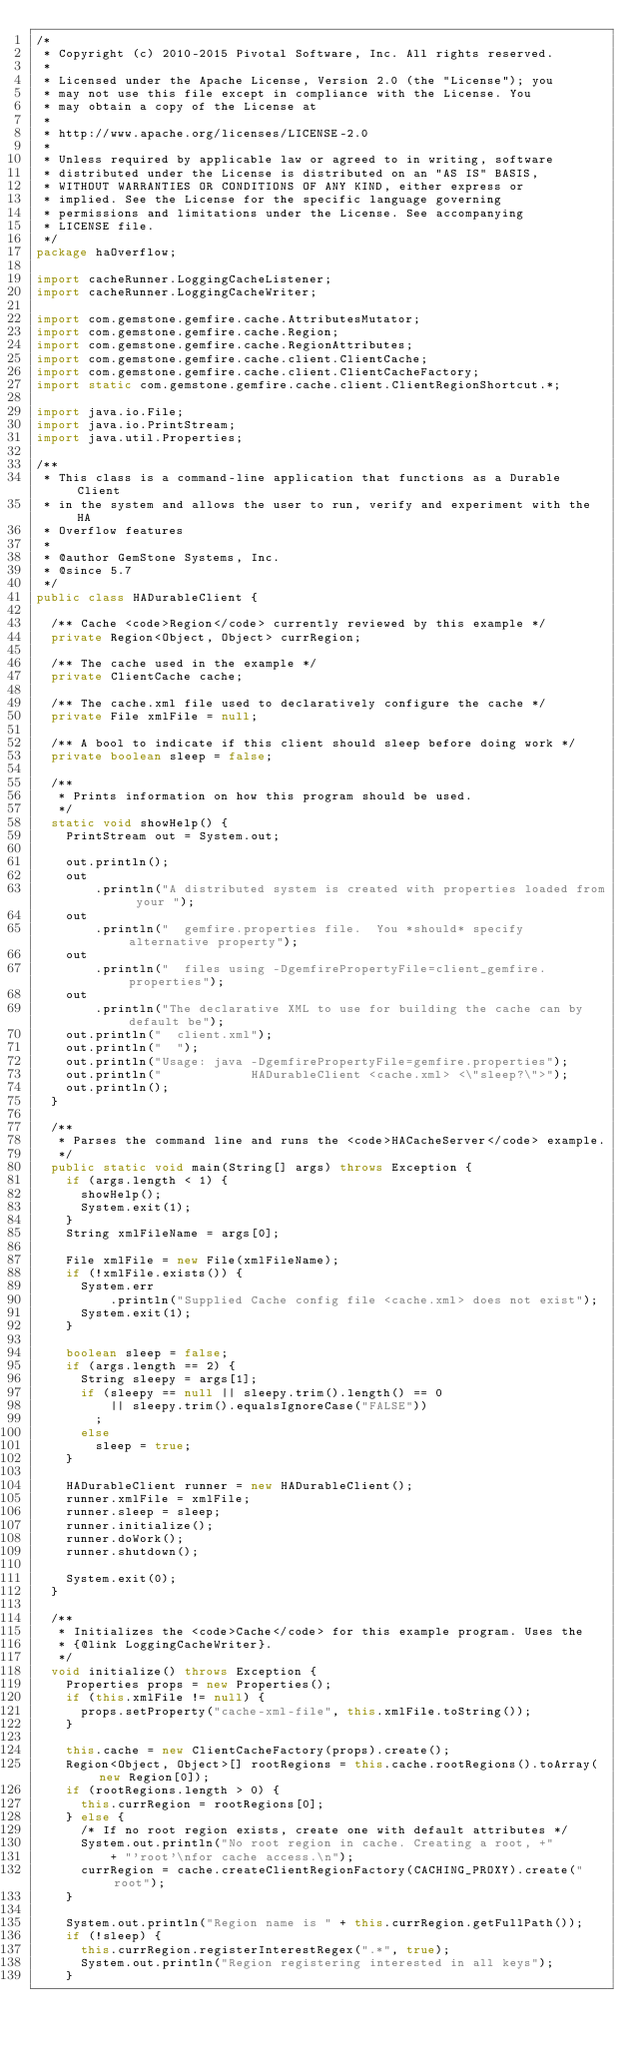Convert code to text. <code><loc_0><loc_0><loc_500><loc_500><_Java_>/*
 * Copyright (c) 2010-2015 Pivotal Software, Inc. All rights reserved.
 *
 * Licensed under the Apache License, Version 2.0 (the "License"); you
 * may not use this file except in compliance with the License. You
 * may obtain a copy of the License at
 *
 * http://www.apache.org/licenses/LICENSE-2.0
 *
 * Unless required by applicable law or agreed to in writing, software
 * distributed under the License is distributed on an "AS IS" BASIS,
 * WITHOUT WARRANTIES OR CONDITIONS OF ANY KIND, either express or
 * implied. See the License for the specific language governing
 * permissions and limitations under the License. See accompanying
 * LICENSE file.
 */
package haOverflow;

import cacheRunner.LoggingCacheListener;
import cacheRunner.LoggingCacheWriter;

import com.gemstone.gemfire.cache.AttributesMutator;
import com.gemstone.gemfire.cache.Region;
import com.gemstone.gemfire.cache.RegionAttributes;
import com.gemstone.gemfire.cache.client.ClientCache;
import com.gemstone.gemfire.cache.client.ClientCacheFactory;
import static com.gemstone.gemfire.cache.client.ClientRegionShortcut.*;

import java.io.File;
import java.io.PrintStream;
import java.util.Properties;

/**
 * This class is a command-line application that functions as a Durable Client
 * in the system and allows the user to run, verify and experiment with the HA
 * Overflow features
 * 
 * @author GemStone Systems, Inc.
 * @since 5.7
 */
public class HADurableClient {

  /** Cache <code>Region</code> currently reviewed by this example */
  private Region<Object, Object> currRegion;

  /** The cache used in the example */
  private ClientCache cache;

  /** The cache.xml file used to declaratively configure the cache */
  private File xmlFile = null;

  /** A bool to indicate if this client should sleep before doing work */
  private boolean sleep = false;

  /**
   * Prints information on how this program should be used.
   */
  static void showHelp() {
    PrintStream out = System.out;

    out.println();
    out
        .println("A distributed system is created with properties loaded from your ");
    out
        .println("  gemfire.properties file.  You *should* specify alternative property");
    out
        .println("  files using -DgemfirePropertyFile=client_gemfire.properties");
    out
        .println("The declarative XML to use for building the cache can by default be");
    out.println("  client.xml");
    out.println("  ");
    out.println("Usage: java -DgemfirePropertyFile=gemfire.properties");
    out.println("            HADurableClient <cache.xml> <\"sleep?\">");
    out.println();
  }

  /**
   * Parses the command line and runs the <code>HACacheServer</code> example.
   */
  public static void main(String[] args) throws Exception {
    if (args.length < 1) {
      showHelp();
      System.exit(1);
    }
    String xmlFileName = args[0];

    File xmlFile = new File(xmlFileName);
    if (!xmlFile.exists()) {
      System.err
          .println("Supplied Cache config file <cache.xml> does not exist");
      System.exit(1);
    }

    boolean sleep = false;
    if (args.length == 2) {
      String sleepy = args[1];
      if (sleepy == null || sleepy.trim().length() == 0
          || sleepy.trim().equalsIgnoreCase("FALSE"))
        ;
      else
        sleep = true;
    }

    HADurableClient runner = new HADurableClient();
    runner.xmlFile = xmlFile;
    runner.sleep = sleep;
    runner.initialize();
    runner.doWork();
    runner.shutdown();

    System.exit(0);
  }

  /**
   * Initializes the <code>Cache</code> for this example program. Uses the
   * {@link LoggingCacheWriter}.
   */
  void initialize() throws Exception {
    Properties props = new Properties();
    if (this.xmlFile != null) {
      props.setProperty("cache-xml-file", this.xmlFile.toString());
    }

    this.cache = new ClientCacheFactory(props).create();
    Region<Object, Object>[] rootRegions = this.cache.rootRegions().toArray(new Region[0]);
    if (rootRegions.length > 0) {
      this.currRegion = rootRegions[0];
    } else {
      /* If no root region exists, create one with default attributes */
      System.out.println("No root region in cache. Creating a root, +"
          + "'root'\nfor cache access.\n");
      currRegion = cache.createClientRegionFactory(CACHING_PROXY).create("root");
    }

    System.out.println("Region name is " + this.currRegion.getFullPath());
    if (!sleep) {
      this.currRegion.registerInterestRegex(".*", true);
      System.out.println("Region registering interested in all keys");
    }
</code> 